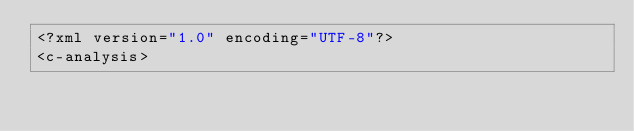<code> <loc_0><loc_0><loc_500><loc_500><_XML_><?xml version="1.0" encoding="UTF-8"?>
<c-analysis></code> 